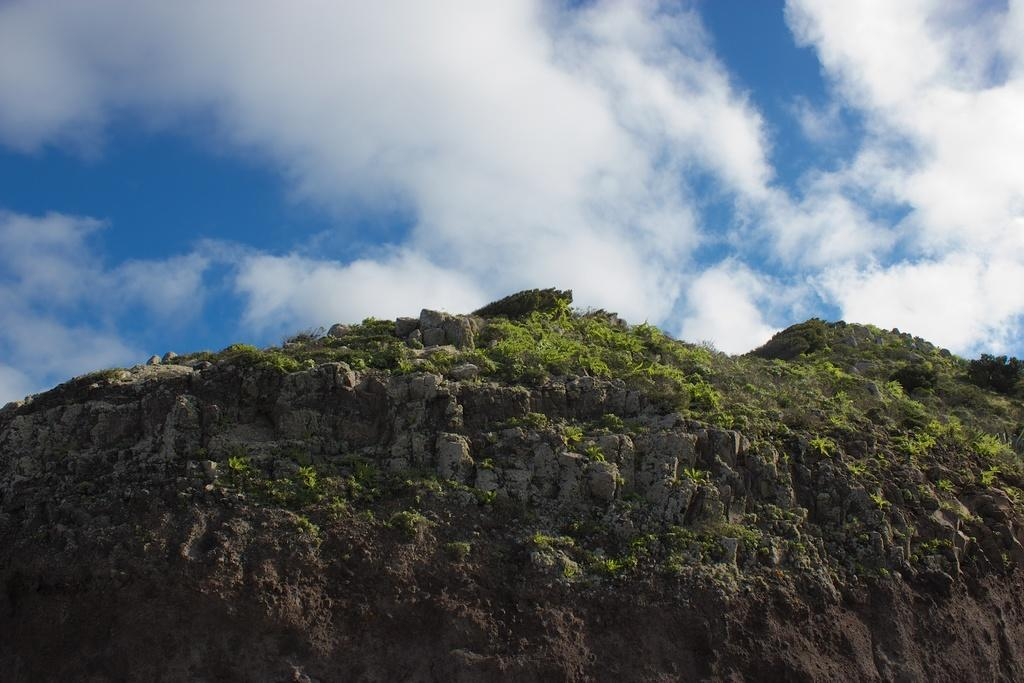What type of geographical feature is present in the image? There are hills in the image. What can be found on the hills in the image? The hills have rocks and plants. What is visible in the background of the image? The background of the image includes a cloudy sky. Where is the field located in the image? There is no field present in the image; it features hills with rocks and plants. Can you tell me how many pieces of furniture are visible in the image? There is no furniture present in the image. 